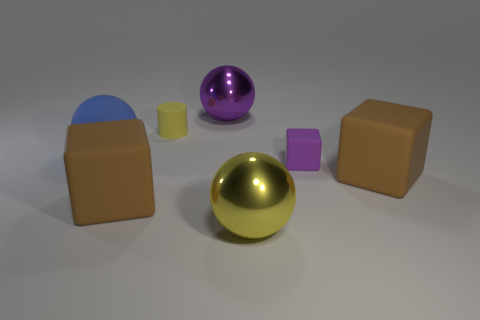How many other big shiny things are the same shape as the big blue thing? 2 